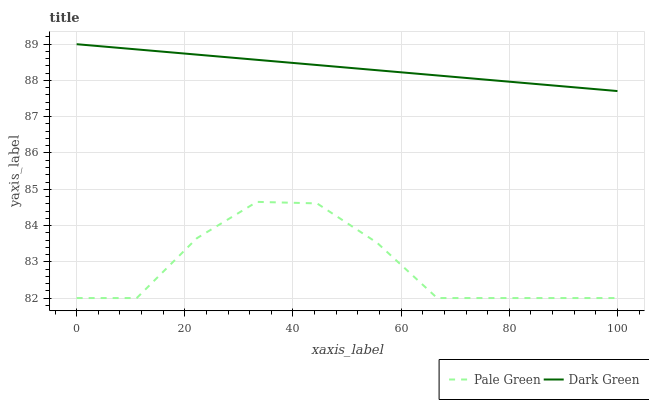Does Pale Green have the minimum area under the curve?
Answer yes or no. Yes. Does Dark Green have the maximum area under the curve?
Answer yes or no. Yes. Does Dark Green have the minimum area under the curve?
Answer yes or no. No. Is Dark Green the smoothest?
Answer yes or no. Yes. Is Pale Green the roughest?
Answer yes or no. Yes. Is Dark Green the roughest?
Answer yes or no. No. Does Pale Green have the lowest value?
Answer yes or no. Yes. Does Dark Green have the lowest value?
Answer yes or no. No. Does Dark Green have the highest value?
Answer yes or no. Yes. Is Pale Green less than Dark Green?
Answer yes or no. Yes. Is Dark Green greater than Pale Green?
Answer yes or no. Yes. Does Pale Green intersect Dark Green?
Answer yes or no. No. 